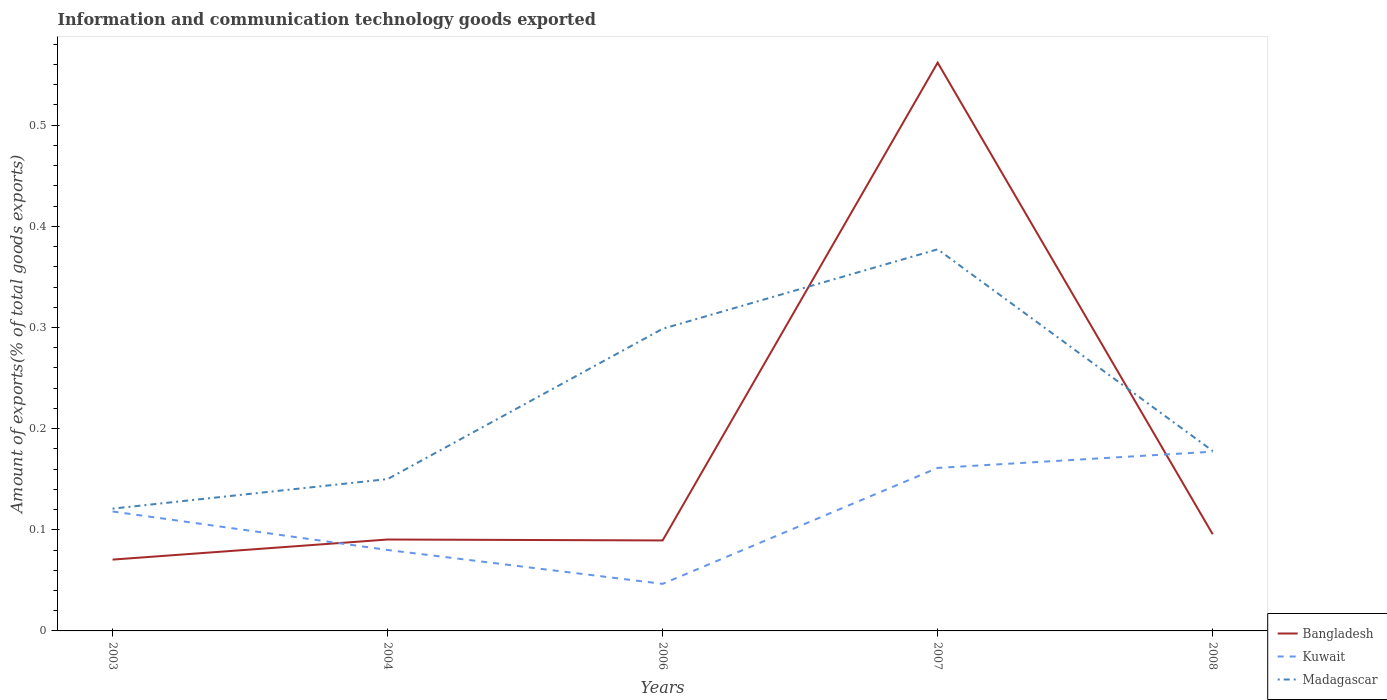How many different coloured lines are there?
Offer a terse response. 3. Does the line corresponding to Madagascar intersect with the line corresponding to Kuwait?
Offer a terse response. No. Across all years, what is the maximum amount of goods exported in Bangladesh?
Your answer should be compact. 0.07. What is the total amount of goods exported in Kuwait in the graph?
Your answer should be very brief. -0.1. What is the difference between the highest and the second highest amount of goods exported in Kuwait?
Offer a terse response. 0.13. What is the difference between the highest and the lowest amount of goods exported in Madagascar?
Your answer should be compact. 2. Is the amount of goods exported in Bangladesh strictly greater than the amount of goods exported in Kuwait over the years?
Ensure brevity in your answer.  No. How many lines are there?
Your answer should be compact. 3. What is the difference between two consecutive major ticks on the Y-axis?
Make the answer very short. 0.1. Does the graph contain any zero values?
Offer a terse response. No. How are the legend labels stacked?
Ensure brevity in your answer.  Vertical. What is the title of the graph?
Offer a terse response. Information and communication technology goods exported. Does "Bhutan" appear as one of the legend labels in the graph?
Your answer should be very brief. No. What is the label or title of the Y-axis?
Ensure brevity in your answer.  Amount of exports(% of total goods exports). What is the Amount of exports(% of total goods exports) in Bangladesh in 2003?
Your answer should be very brief. 0.07. What is the Amount of exports(% of total goods exports) in Kuwait in 2003?
Provide a short and direct response. 0.12. What is the Amount of exports(% of total goods exports) of Madagascar in 2003?
Provide a succinct answer. 0.12. What is the Amount of exports(% of total goods exports) of Bangladesh in 2004?
Your response must be concise. 0.09. What is the Amount of exports(% of total goods exports) of Kuwait in 2004?
Provide a succinct answer. 0.08. What is the Amount of exports(% of total goods exports) of Madagascar in 2004?
Offer a very short reply. 0.15. What is the Amount of exports(% of total goods exports) of Bangladesh in 2006?
Keep it short and to the point. 0.09. What is the Amount of exports(% of total goods exports) in Kuwait in 2006?
Your answer should be very brief. 0.05. What is the Amount of exports(% of total goods exports) of Madagascar in 2006?
Give a very brief answer. 0.3. What is the Amount of exports(% of total goods exports) of Bangladesh in 2007?
Your response must be concise. 0.56. What is the Amount of exports(% of total goods exports) in Kuwait in 2007?
Keep it short and to the point. 0.16. What is the Amount of exports(% of total goods exports) of Madagascar in 2007?
Offer a very short reply. 0.38. What is the Amount of exports(% of total goods exports) in Bangladesh in 2008?
Give a very brief answer. 0.1. What is the Amount of exports(% of total goods exports) of Kuwait in 2008?
Provide a succinct answer. 0.18. What is the Amount of exports(% of total goods exports) in Madagascar in 2008?
Provide a succinct answer. 0.18. Across all years, what is the maximum Amount of exports(% of total goods exports) in Bangladesh?
Your response must be concise. 0.56. Across all years, what is the maximum Amount of exports(% of total goods exports) of Kuwait?
Your response must be concise. 0.18. Across all years, what is the maximum Amount of exports(% of total goods exports) in Madagascar?
Provide a short and direct response. 0.38. Across all years, what is the minimum Amount of exports(% of total goods exports) of Bangladesh?
Give a very brief answer. 0.07. Across all years, what is the minimum Amount of exports(% of total goods exports) of Kuwait?
Offer a very short reply. 0.05. Across all years, what is the minimum Amount of exports(% of total goods exports) of Madagascar?
Make the answer very short. 0.12. What is the total Amount of exports(% of total goods exports) in Bangladesh in the graph?
Provide a short and direct response. 0.91. What is the total Amount of exports(% of total goods exports) in Kuwait in the graph?
Your response must be concise. 0.58. What is the total Amount of exports(% of total goods exports) in Madagascar in the graph?
Make the answer very short. 1.12. What is the difference between the Amount of exports(% of total goods exports) of Bangladesh in 2003 and that in 2004?
Your answer should be very brief. -0.02. What is the difference between the Amount of exports(% of total goods exports) of Kuwait in 2003 and that in 2004?
Your answer should be compact. 0.04. What is the difference between the Amount of exports(% of total goods exports) in Madagascar in 2003 and that in 2004?
Make the answer very short. -0.03. What is the difference between the Amount of exports(% of total goods exports) of Bangladesh in 2003 and that in 2006?
Your answer should be compact. -0.02. What is the difference between the Amount of exports(% of total goods exports) in Kuwait in 2003 and that in 2006?
Provide a succinct answer. 0.07. What is the difference between the Amount of exports(% of total goods exports) in Madagascar in 2003 and that in 2006?
Provide a succinct answer. -0.18. What is the difference between the Amount of exports(% of total goods exports) of Bangladesh in 2003 and that in 2007?
Provide a succinct answer. -0.49. What is the difference between the Amount of exports(% of total goods exports) in Kuwait in 2003 and that in 2007?
Your answer should be very brief. -0.04. What is the difference between the Amount of exports(% of total goods exports) of Madagascar in 2003 and that in 2007?
Your answer should be compact. -0.26. What is the difference between the Amount of exports(% of total goods exports) of Bangladesh in 2003 and that in 2008?
Offer a terse response. -0.03. What is the difference between the Amount of exports(% of total goods exports) in Kuwait in 2003 and that in 2008?
Ensure brevity in your answer.  -0.06. What is the difference between the Amount of exports(% of total goods exports) of Madagascar in 2003 and that in 2008?
Your response must be concise. -0.06. What is the difference between the Amount of exports(% of total goods exports) in Bangladesh in 2004 and that in 2006?
Provide a succinct answer. 0. What is the difference between the Amount of exports(% of total goods exports) of Kuwait in 2004 and that in 2006?
Keep it short and to the point. 0.03. What is the difference between the Amount of exports(% of total goods exports) of Madagascar in 2004 and that in 2006?
Your answer should be compact. -0.15. What is the difference between the Amount of exports(% of total goods exports) of Bangladesh in 2004 and that in 2007?
Your response must be concise. -0.47. What is the difference between the Amount of exports(% of total goods exports) in Kuwait in 2004 and that in 2007?
Ensure brevity in your answer.  -0.08. What is the difference between the Amount of exports(% of total goods exports) in Madagascar in 2004 and that in 2007?
Your response must be concise. -0.23. What is the difference between the Amount of exports(% of total goods exports) in Bangladesh in 2004 and that in 2008?
Make the answer very short. -0.01. What is the difference between the Amount of exports(% of total goods exports) in Kuwait in 2004 and that in 2008?
Offer a very short reply. -0.1. What is the difference between the Amount of exports(% of total goods exports) in Madagascar in 2004 and that in 2008?
Provide a short and direct response. -0.03. What is the difference between the Amount of exports(% of total goods exports) in Bangladesh in 2006 and that in 2007?
Ensure brevity in your answer.  -0.47. What is the difference between the Amount of exports(% of total goods exports) of Kuwait in 2006 and that in 2007?
Offer a very short reply. -0.11. What is the difference between the Amount of exports(% of total goods exports) in Madagascar in 2006 and that in 2007?
Keep it short and to the point. -0.08. What is the difference between the Amount of exports(% of total goods exports) of Bangladesh in 2006 and that in 2008?
Give a very brief answer. -0.01. What is the difference between the Amount of exports(% of total goods exports) in Kuwait in 2006 and that in 2008?
Provide a succinct answer. -0.13. What is the difference between the Amount of exports(% of total goods exports) in Madagascar in 2006 and that in 2008?
Offer a terse response. 0.12. What is the difference between the Amount of exports(% of total goods exports) of Bangladesh in 2007 and that in 2008?
Give a very brief answer. 0.47. What is the difference between the Amount of exports(% of total goods exports) of Kuwait in 2007 and that in 2008?
Offer a very short reply. -0.02. What is the difference between the Amount of exports(% of total goods exports) of Madagascar in 2007 and that in 2008?
Give a very brief answer. 0.2. What is the difference between the Amount of exports(% of total goods exports) in Bangladesh in 2003 and the Amount of exports(% of total goods exports) in Kuwait in 2004?
Make the answer very short. -0.01. What is the difference between the Amount of exports(% of total goods exports) in Bangladesh in 2003 and the Amount of exports(% of total goods exports) in Madagascar in 2004?
Your answer should be compact. -0.08. What is the difference between the Amount of exports(% of total goods exports) of Kuwait in 2003 and the Amount of exports(% of total goods exports) of Madagascar in 2004?
Offer a very short reply. -0.03. What is the difference between the Amount of exports(% of total goods exports) in Bangladesh in 2003 and the Amount of exports(% of total goods exports) in Kuwait in 2006?
Provide a short and direct response. 0.02. What is the difference between the Amount of exports(% of total goods exports) in Bangladesh in 2003 and the Amount of exports(% of total goods exports) in Madagascar in 2006?
Offer a terse response. -0.23. What is the difference between the Amount of exports(% of total goods exports) of Kuwait in 2003 and the Amount of exports(% of total goods exports) of Madagascar in 2006?
Ensure brevity in your answer.  -0.18. What is the difference between the Amount of exports(% of total goods exports) of Bangladesh in 2003 and the Amount of exports(% of total goods exports) of Kuwait in 2007?
Your response must be concise. -0.09. What is the difference between the Amount of exports(% of total goods exports) in Bangladesh in 2003 and the Amount of exports(% of total goods exports) in Madagascar in 2007?
Make the answer very short. -0.31. What is the difference between the Amount of exports(% of total goods exports) in Kuwait in 2003 and the Amount of exports(% of total goods exports) in Madagascar in 2007?
Provide a succinct answer. -0.26. What is the difference between the Amount of exports(% of total goods exports) of Bangladesh in 2003 and the Amount of exports(% of total goods exports) of Kuwait in 2008?
Your answer should be very brief. -0.11. What is the difference between the Amount of exports(% of total goods exports) in Bangladesh in 2003 and the Amount of exports(% of total goods exports) in Madagascar in 2008?
Provide a succinct answer. -0.11. What is the difference between the Amount of exports(% of total goods exports) in Kuwait in 2003 and the Amount of exports(% of total goods exports) in Madagascar in 2008?
Make the answer very short. -0.06. What is the difference between the Amount of exports(% of total goods exports) of Bangladesh in 2004 and the Amount of exports(% of total goods exports) of Kuwait in 2006?
Your answer should be very brief. 0.04. What is the difference between the Amount of exports(% of total goods exports) in Bangladesh in 2004 and the Amount of exports(% of total goods exports) in Madagascar in 2006?
Offer a terse response. -0.21. What is the difference between the Amount of exports(% of total goods exports) in Kuwait in 2004 and the Amount of exports(% of total goods exports) in Madagascar in 2006?
Make the answer very short. -0.22. What is the difference between the Amount of exports(% of total goods exports) in Bangladesh in 2004 and the Amount of exports(% of total goods exports) in Kuwait in 2007?
Your response must be concise. -0.07. What is the difference between the Amount of exports(% of total goods exports) of Bangladesh in 2004 and the Amount of exports(% of total goods exports) of Madagascar in 2007?
Make the answer very short. -0.29. What is the difference between the Amount of exports(% of total goods exports) in Kuwait in 2004 and the Amount of exports(% of total goods exports) in Madagascar in 2007?
Your response must be concise. -0.3. What is the difference between the Amount of exports(% of total goods exports) of Bangladesh in 2004 and the Amount of exports(% of total goods exports) of Kuwait in 2008?
Give a very brief answer. -0.09. What is the difference between the Amount of exports(% of total goods exports) in Bangladesh in 2004 and the Amount of exports(% of total goods exports) in Madagascar in 2008?
Your response must be concise. -0.09. What is the difference between the Amount of exports(% of total goods exports) in Kuwait in 2004 and the Amount of exports(% of total goods exports) in Madagascar in 2008?
Offer a very short reply. -0.1. What is the difference between the Amount of exports(% of total goods exports) in Bangladesh in 2006 and the Amount of exports(% of total goods exports) in Kuwait in 2007?
Provide a short and direct response. -0.07. What is the difference between the Amount of exports(% of total goods exports) of Bangladesh in 2006 and the Amount of exports(% of total goods exports) of Madagascar in 2007?
Give a very brief answer. -0.29. What is the difference between the Amount of exports(% of total goods exports) in Kuwait in 2006 and the Amount of exports(% of total goods exports) in Madagascar in 2007?
Offer a terse response. -0.33. What is the difference between the Amount of exports(% of total goods exports) of Bangladesh in 2006 and the Amount of exports(% of total goods exports) of Kuwait in 2008?
Ensure brevity in your answer.  -0.09. What is the difference between the Amount of exports(% of total goods exports) of Bangladesh in 2006 and the Amount of exports(% of total goods exports) of Madagascar in 2008?
Your answer should be very brief. -0.09. What is the difference between the Amount of exports(% of total goods exports) in Kuwait in 2006 and the Amount of exports(% of total goods exports) in Madagascar in 2008?
Offer a very short reply. -0.13. What is the difference between the Amount of exports(% of total goods exports) of Bangladesh in 2007 and the Amount of exports(% of total goods exports) of Kuwait in 2008?
Offer a very short reply. 0.38. What is the difference between the Amount of exports(% of total goods exports) in Bangladesh in 2007 and the Amount of exports(% of total goods exports) in Madagascar in 2008?
Provide a succinct answer. 0.38. What is the difference between the Amount of exports(% of total goods exports) of Kuwait in 2007 and the Amount of exports(% of total goods exports) of Madagascar in 2008?
Offer a terse response. -0.02. What is the average Amount of exports(% of total goods exports) of Bangladesh per year?
Your answer should be compact. 0.18. What is the average Amount of exports(% of total goods exports) of Kuwait per year?
Your answer should be very brief. 0.12. What is the average Amount of exports(% of total goods exports) in Madagascar per year?
Your response must be concise. 0.23. In the year 2003, what is the difference between the Amount of exports(% of total goods exports) of Bangladesh and Amount of exports(% of total goods exports) of Kuwait?
Your answer should be very brief. -0.05. In the year 2003, what is the difference between the Amount of exports(% of total goods exports) of Bangladesh and Amount of exports(% of total goods exports) of Madagascar?
Ensure brevity in your answer.  -0.05. In the year 2003, what is the difference between the Amount of exports(% of total goods exports) of Kuwait and Amount of exports(% of total goods exports) of Madagascar?
Ensure brevity in your answer.  -0. In the year 2004, what is the difference between the Amount of exports(% of total goods exports) of Bangladesh and Amount of exports(% of total goods exports) of Kuwait?
Provide a short and direct response. 0.01. In the year 2004, what is the difference between the Amount of exports(% of total goods exports) of Bangladesh and Amount of exports(% of total goods exports) of Madagascar?
Your answer should be compact. -0.06. In the year 2004, what is the difference between the Amount of exports(% of total goods exports) in Kuwait and Amount of exports(% of total goods exports) in Madagascar?
Provide a succinct answer. -0.07. In the year 2006, what is the difference between the Amount of exports(% of total goods exports) in Bangladesh and Amount of exports(% of total goods exports) in Kuwait?
Offer a very short reply. 0.04. In the year 2006, what is the difference between the Amount of exports(% of total goods exports) in Bangladesh and Amount of exports(% of total goods exports) in Madagascar?
Ensure brevity in your answer.  -0.21. In the year 2006, what is the difference between the Amount of exports(% of total goods exports) in Kuwait and Amount of exports(% of total goods exports) in Madagascar?
Your answer should be very brief. -0.25. In the year 2007, what is the difference between the Amount of exports(% of total goods exports) in Bangladesh and Amount of exports(% of total goods exports) in Kuwait?
Your answer should be compact. 0.4. In the year 2007, what is the difference between the Amount of exports(% of total goods exports) in Bangladesh and Amount of exports(% of total goods exports) in Madagascar?
Offer a very short reply. 0.18. In the year 2007, what is the difference between the Amount of exports(% of total goods exports) in Kuwait and Amount of exports(% of total goods exports) in Madagascar?
Keep it short and to the point. -0.22. In the year 2008, what is the difference between the Amount of exports(% of total goods exports) of Bangladesh and Amount of exports(% of total goods exports) of Kuwait?
Your answer should be compact. -0.08. In the year 2008, what is the difference between the Amount of exports(% of total goods exports) of Bangladesh and Amount of exports(% of total goods exports) of Madagascar?
Your answer should be very brief. -0.08. In the year 2008, what is the difference between the Amount of exports(% of total goods exports) in Kuwait and Amount of exports(% of total goods exports) in Madagascar?
Provide a short and direct response. -0. What is the ratio of the Amount of exports(% of total goods exports) in Bangladesh in 2003 to that in 2004?
Offer a very short reply. 0.78. What is the ratio of the Amount of exports(% of total goods exports) of Kuwait in 2003 to that in 2004?
Offer a very short reply. 1.48. What is the ratio of the Amount of exports(% of total goods exports) in Madagascar in 2003 to that in 2004?
Ensure brevity in your answer.  0.81. What is the ratio of the Amount of exports(% of total goods exports) of Bangladesh in 2003 to that in 2006?
Make the answer very short. 0.79. What is the ratio of the Amount of exports(% of total goods exports) in Kuwait in 2003 to that in 2006?
Give a very brief answer. 2.54. What is the ratio of the Amount of exports(% of total goods exports) of Madagascar in 2003 to that in 2006?
Your answer should be compact. 0.4. What is the ratio of the Amount of exports(% of total goods exports) of Bangladesh in 2003 to that in 2007?
Ensure brevity in your answer.  0.13. What is the ratio of the Amount of exports(% of total goods exports) in Kuwait in 2003 to that in 2007?
Make the answer very short. 0.73. What is the ratio of the Amount of exports(% of total goods exports) of Madagascar in 2003 to that in 2007?
Offer a terse response. 0.32. What is the ratio of the Amount of exports(% of total goods exports) of Bangladesh in 2003 to that in 2008?
Offer a terse response. 0.74. What is the ratio of the Amount of exports(% of total goods exports) of Kuwait in 2003 to that in 2008?
Give a very brief answer. 0.67. What is the ratio of the Amount of exports(% of total goods exports) in Madagascar in 2003 to that in 2008?
Give a very brief answer. 0.68. What is the ratio of the Amount of exports(% of total goods exports) in Bangladesh in 2004 to that in 2006?
Offer a very short reply. 1.01. What is the ratio of the Amount of exports(% of total goods exports) of Kuwait in 2004 to that in 2006?
Offer a terse response. 1.72. What is the ratio of the Amount of exports(% of total goods exports) in Madagascar in 2004 to that in 2006?
Give a very brief answer. 0.5. What is the ratio of the Amount of exports(% of total goods exports) of Bangladesh in 2004 to that in 2007?
Keep it short and to the point. 0.16. What is the ratio of the Amount of exports(% of total goods exports) of Kuwait in 2004 to that in 2007?
Keep it short and to the point. 0.5. What is the ratio of the Amount of exports(% of total goods exports) of Madagascar in 2004 to that in 2007?
Give a very brief answer. 0.4. What is the ratio of the Amount of exports(% of total goods exports) of Bangladesh in 2004 to that in 2008?
Ensure brevity in your answer.  0.95. What is the ratio of the Amount of exports(% of total goods exports) of Kuwait in 2004 to that in 2008?
Your answer should be compact. 0.45. What is the ratio of the Amount of exports(% of total goods exports) in Madagascar in 2004 to that in 2008?
Give a very brief answer. 0.84. What is the ratio of the Amount of exports(% of total goods exports) of Bangladesh in 2006 to that in 2007?
Provide a short and direct response. 0.16. What is the ratio of the Amount of exports(% of total goods exports) of Kuwait in 2006 to that in 2007?
Ensure brevity in your answer.  0.29. What is the ratio of the Amount of exports(% of total goods exports) of Madagascar in 2006 to that in 2007?
Give a very brief answer. 0.79. What is the ratio of the Amount of exports(% of total goods exports) of Bangladesh in 2006 to that in 2008?
Provide a short and direct response. 0.94. What is the ratio of the Amount of exports(% of total goods exports) of Kuwait in 2006 to that in 2008?
Offer a terse response. 0.26. What is the ratio of the Amount of exports(% of total goods exports) in Madagascar in 2006 to that in 2008?
Make the answer very short. 1.68. What is the ratio of the Amount of exports(% of total goods exports) of Bangladesh in 2007 to that in 2008?
Offer a terse response. 5.88. What is the ratio of the Amount of exports(% of total goods exports) of Kuwait in 2007 to that in 2008?
Your answer should be compact. 0.91. What is the ratio of the Amount of exports(% of total goods exports) of Madagascar in 2007 to that in 2008?
Provide a succinct answer. 2.12. What is the difference between the highest and the second highest Amount of exports(% of total goods exports) in Bangladesh?
Make the answer very short. 0.47. What is the difference between the highest and the second highest Amount of exports(% of total goods exports) in Kuwait?
Your answer should be very brief. 0.02. What is the difference between the highest and the second highest Amount of exports(% of total goods exports) in Madagascar?
Offer a terse response. 0.08. What is the difference between the highest and the lowest Amount of exports(% of total goods exports) in Bangladesh?
Ensure brevity in your answer.  0.49. What is the difference between the highest and the lowest Amount of exports(% of total goods exports) in Kuwait?
Your answer should be very brief. 0.13. What is the difference between the highest and the lowest Amount of exports(% of total goods exports) in Madagascar?
Provide a succinct answer. 0.26. 